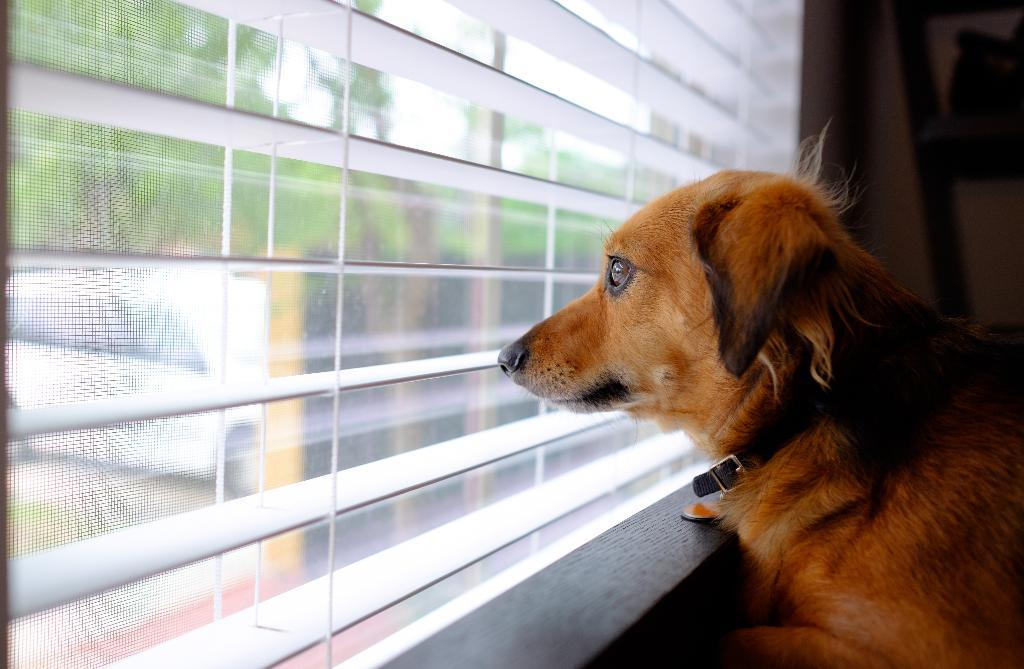What type of animal is in the image? There is a dog in the image. What is in front of the dog? There is a glass window in front of the dog. What can be seen through the glass window? Trees, a car, and the sky are visible through the glass window. How does the dog wash its paws in the image? The dog does not wash its paws in the image; there is no indication of any such activity. 